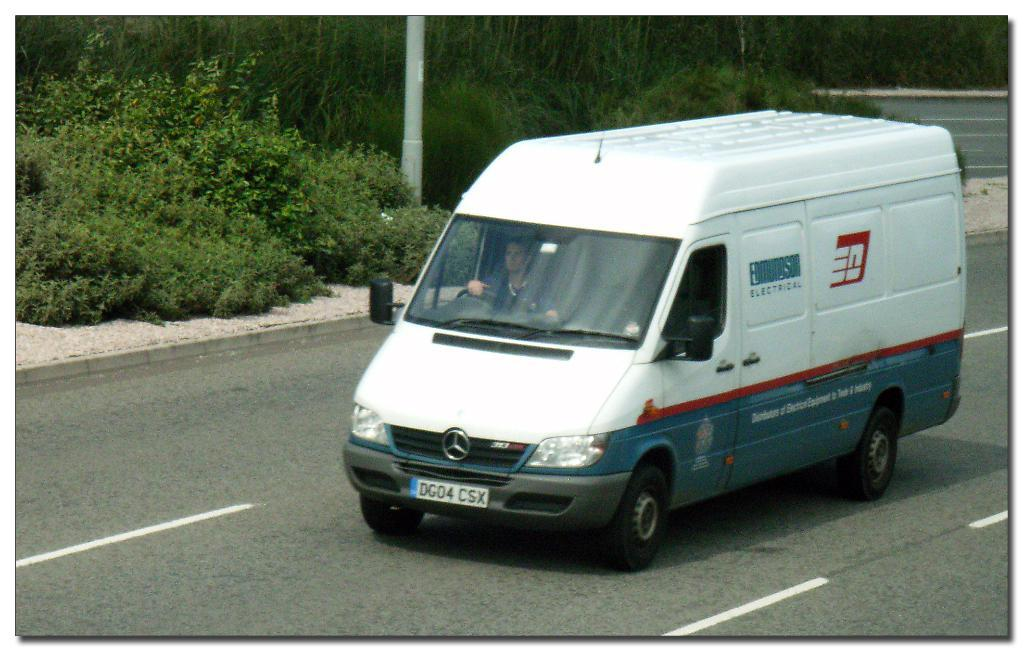What is the main subject of the image? There is a man in the image. What is the man doing in the image? The man is driving a van. Can you describe the van in the image? The van is white in color. What can be seen in the background of the image? There are trees and a pole in the background of the image. Can you see a beetle crawling on the floor in the image? There is no beetle or floor present in the image; it features a man driving a white van with a background of trees and a pole. 